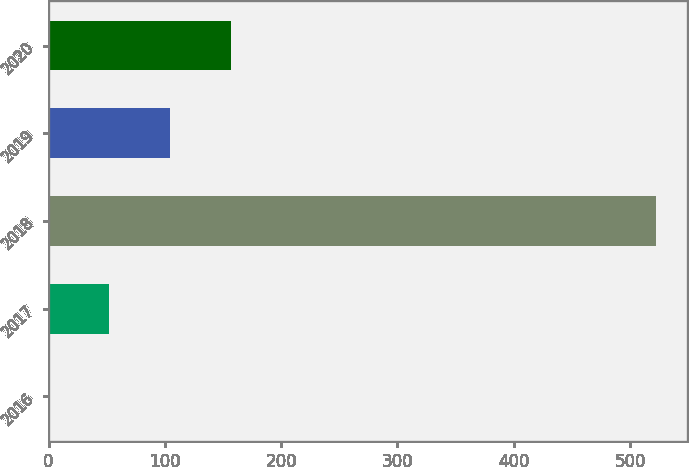Convert chart to OTSL. <chart><loc_0><loc_0><loc_500><loc_500><bar_chart><fcel>2016<fcel>2017<fcel>2018<fcel>2019<fcel>2020<nl><fcel>0.1<fcel>52.34<fcel>522.5<fcel>104.58<fcel>156.82<nl></chart> 